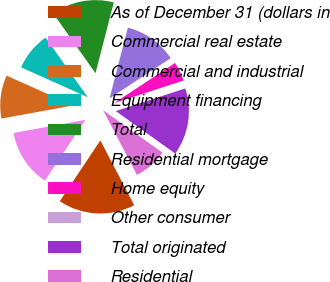<chart> <loc_0><loc_0><loc_500><loc_500><pie_chart><fcel>As of December 31 (dollars in<fcel>Commercial real estate<fcel>Commercial and industrial<fcel>Equipment financing<fcel>Total<fcel>Residential mortgage<fcel>Home equity<fcel>Other consumer<fcel>Total originated<fcel>Residential<nl><fcel>17.02%<fcel>12.77%<fcel>9.57%<fcel>8.51%<fcel>13.83%<fcel>11.7%<fcel>4.26%<fcel>0.0%<fcel>14.89%<fcel>7.45%<nl></chart> 